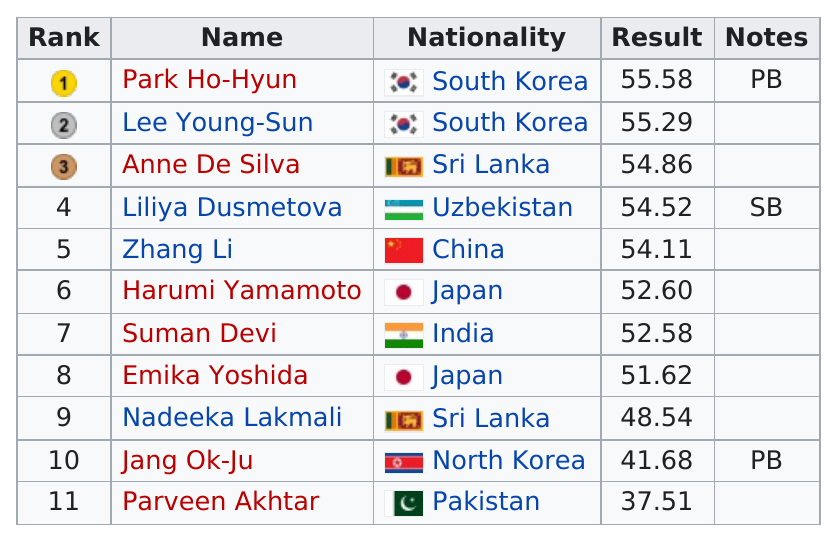Give some essential details in this illustration. A total of three competitors from North and South Korea combined participated in the event. There are approximately 11 names. Japan had the most results below 53. The person who medaled but was not from South Korea is Anne De Silva. Toshida did not perform better than Lee Young-Sun. 